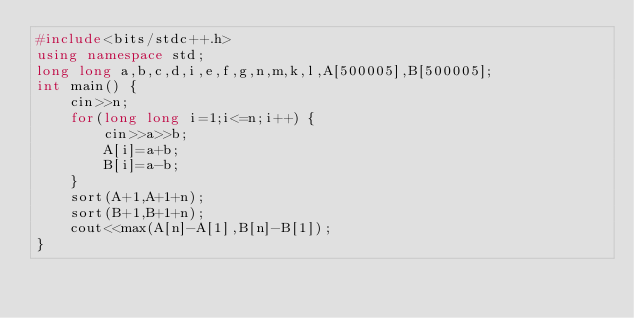Convert code to text. <code><loc_0><loc_0><loc_500><loc_500><_C++_>#include<bits/stdc++.h>
using namespace std;
long long a,b,c,d,i,e,f,g,n,m,k,l,A[500005],B[500005];
int main() {
    cin>>n;
    for(long long i=1;i<=n;i++) {
        cin>>a>>b;
        A[i]=a+b;
        B[i]=a-b;
    }
    sort(A+1,A+1+n);
    sort(B+1,B+1+n);
    cout<<max(A[n]-A[1],B[n]-B[1]);
}</code> 